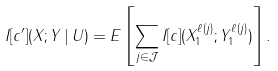Convert formula to latex. <formula><loc_0><loc_0><loc_500><loc_500>I [ c ^ { \prime } ] ( X ; Y \, | \, U ) = E \left [ \sum _ { j \in \mathcal { J } } I [ c ] ( X _ { 1 } ^ { \ell ( j ) } ; Y _ { 1 } ^ { \ell ( j ) } ) \right ] .</formula> 